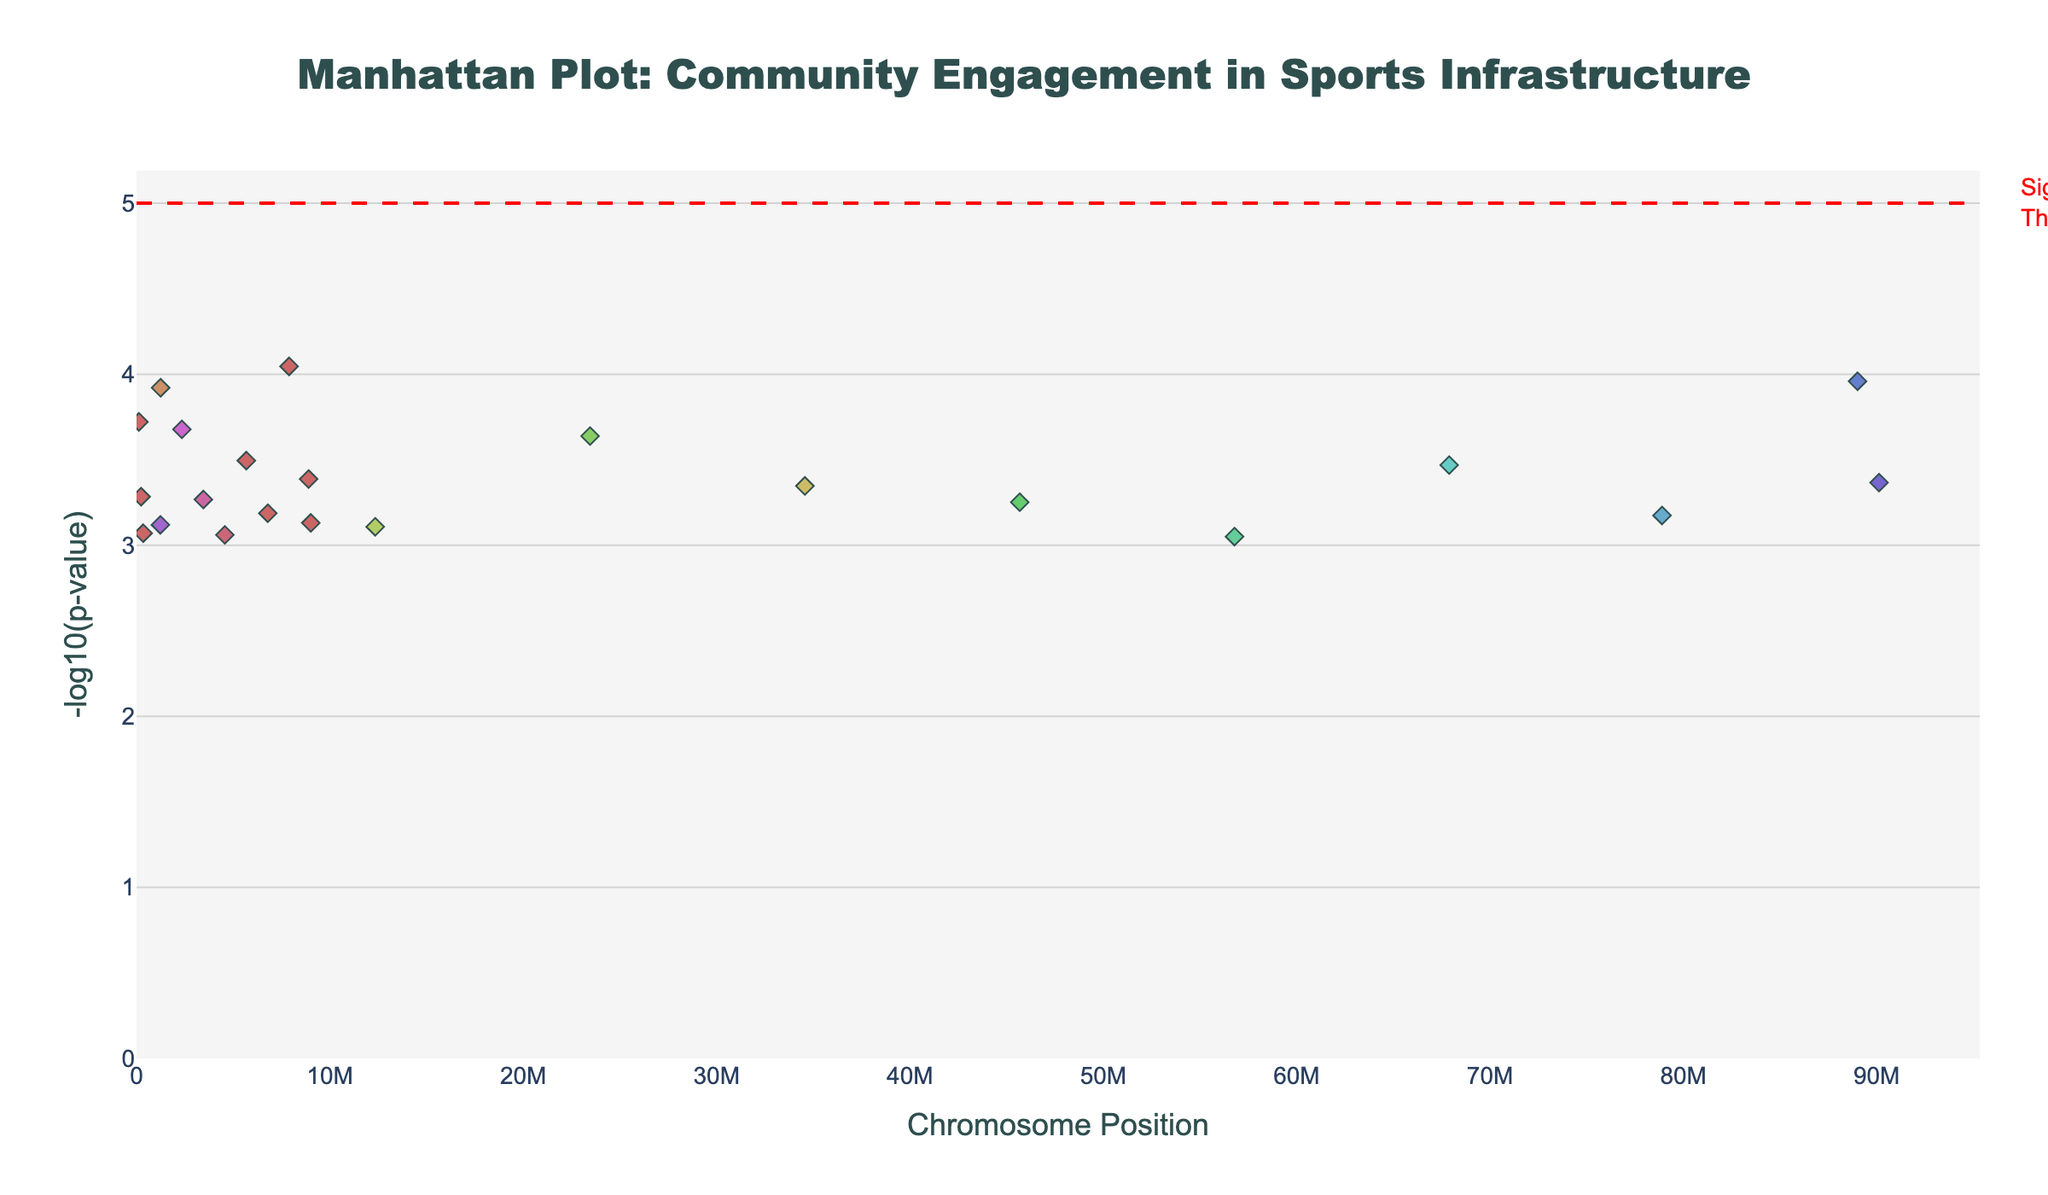What is the title of the plot? The title is displayed prominently at the top of the plot.
Answer: Manhattan Plot: Community Engagement in Sports Infrastructure On which chromosome does the gene BDNF occur? By inspecting the hover text and positions, BDNF is associated with chromosome 9.
Answer: Chromosome 9 What color represents points on chromosome 5? Each chromosome has a distinct color. Chromosome 5 points are colored in a specific hue according to the color mapping used in the plot.
Answer: Light blue What is the significance threshold level (-log10(p-value))? There is a horizontal line drawn at a certain y-level representing the significance threshold. This is labeled as "Significance Threshold".
Answer: 5 Which gene has the lowest p-value, and on which chromosome is it located? The lowest p-value corresponds to the highest -log10(p-value) in the y-axis. Gene SLC6A3 on chromosome 17 has the highest y-value.
Answer: SLC6A3 on chromosome 17 Approximately what is the -log10(p-value) of the gene COMT on chromosome 20? The plot allows us to hover over specific points to see the corresponding gene and p-value. The y-value (height) of the point for COMT on chromosome 20 can be read directly.
Answer: About 3.72 Is there any gene on chromosome 12 that has a -log10(p-value) above the significance threshold? By examining points on chromosome 12 and their corresponding y-values, no points exceed the horizontal line at y=5.
Answer: No Which chromosomes have multiple genes associated with the community engagement data? By counting the number of distinct points per chromosome, chromosomes 2 and 19 each have two points/gene names.
Answer: Chromosomes 2 and 19 How many genes have a -log10(p-value) greater than 3? By counting the points that cross the y=3 threshold, it can be determined how many genes surpass this value.
Answer: 22 Which gene on chromosome 15 has a -log10(p-value) close to 3.5? By examining the hover-text information for points on chromosome 15, the gene with a -log10(p-value) near 3.5 is FOXP2.
Answer: FOXP2 